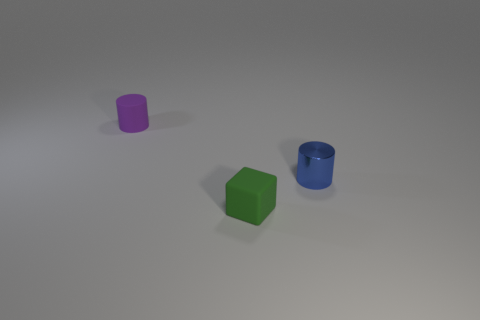Subtract all cylinders. How many objects are left? 1 Add 1 purple metallic spheres. How many objects exist? 4 Add 1 blue shiny cylinders. How many blue shiny cylinders are left? 2 Add 1 big yellow things. How many big yellow things exist? 1 Subtract 0 cyan spheres. How many objects are left? 3 Subtract all purple cylinders. Subtract all large purple cubes. How many objects are left? 2 